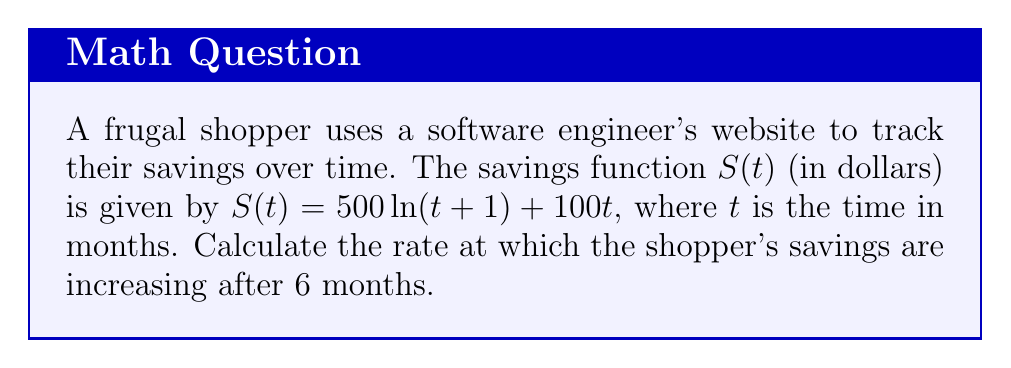Could you help me with this problem? To find the rate at which the shopper's savings are increasing after 6 months, we need to calculate the derivative of the savings function $S(t)$ and evaluate it at $t = 6$.

1. Given savings function: $S(t) = 500\ln(t+1) + 100t$

2. Calculate the derivative $S'(t)$ using the sum rule and chain rule:
   $$S'(t) = 500 \cdot \frac{d}{dt}[\ln(t+1)] + 100 \cdot \frac{d}{dt}[t]$$
   $$S'(t) = 500 \cdot \frac{1}{t+1} + 100$$

3. Simplify the derivative:
   $$S'(t) = \frac{500}{t+1} + 100$$

4. Evaluate $S'(t)$ at $t = 6$:
   $$S'(6) = \frac{500}{6+1} + 100$$
   $$S'(6) = \frac{500}{7} + 100$$
   $$S'(6) = 71.43 + 100$$
   $$S'(6) = 171.43$$

The rate at which the shopper's savings are increasing after 6 months is approximately $171.43 dollars per month.
Answer: $171.43 dollars per month 